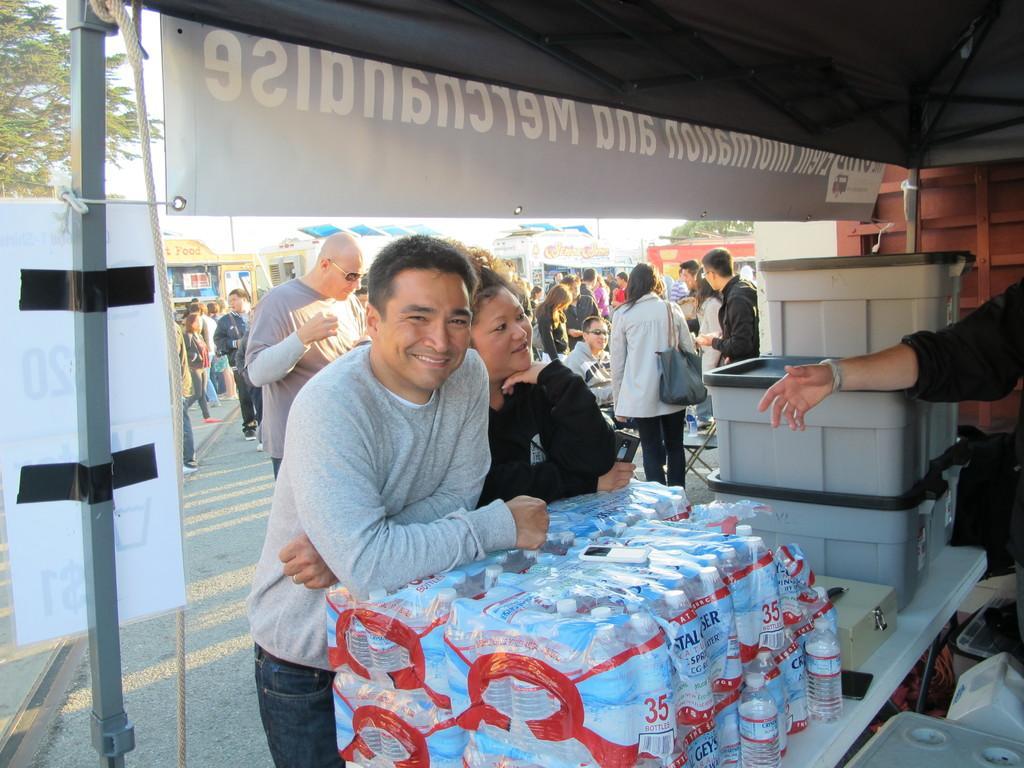How would you summarize this image in a sentence or two? In the center of the image we can see two persons are standing and they are smiling. In front of them, there is a table. On the table, we can see boxes, water bottles in the plastic packets, one phone and a few other objects. In the right side of the image, we can see one person standing and we can see few other objects. In the background we can see the sky, trees, shops, banners, poles, few people are standing, few people are holding some objects and a few other objects. 